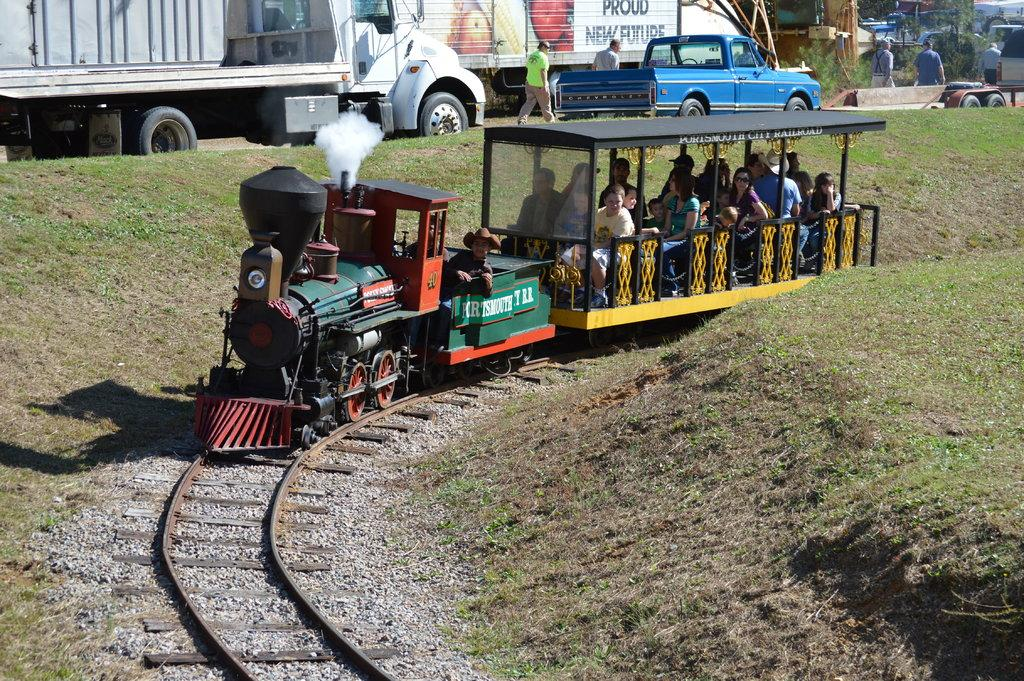What is the main subject of the image? There is a train in the image. Are there any passengers in the train? Yes, there are people in the train. What is the train's mode of transportation? The train is on tracks. What is the ground like in the image? The ground is covered with grass and stones. What other types of transportation can be seen in the image? There are vehicles in the image. Can you identify any living organisms in the image? Yes, there are people and trees visible in the image. What type of frame is holding the room together in the image? There is no room or frame present in the image; it features a train on tracks with people and vehicles in the surrounding environment. 